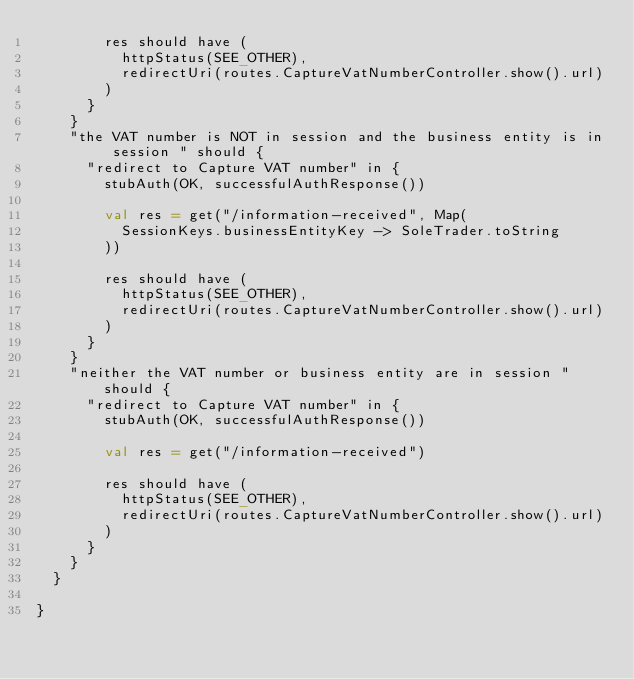<code> <loc_0><loc_0><loc_500><loc_500><_Scala_>        res should have (
          httpStatus(SEE_OTHER),
          redirectUri(routes.CaptureVatNumberController.show().url)
        )
      }
    }
    "the VAT number is NOT in session and the business entity is in session " should {
      "redirect to Capture VAT number" in {
        stubAuth(OK, successfulAuthResponse())

        val res = get("/information-received", Map(
          SessionKeys.businessEntityKey -> SoleTrader.toString
        ))

        res should have (
          httpStatus(SEE_OTHER),
          redirectUri(routes.CaptureVatNumberController.show().url)
        )
      }
    }
    "neither the VAT number or business entity are in session " should {
      "redirect to Capture VAT number" in {
        stubAuth(OK, successfulAuthResponse())

        val res = get("/information-received")

        res should have (
          httpStatus(SEE_OTHER),
          redirectUri(routes.CaptureVatNumberController.show().url)
        )
      }
    }
  }

}
</code> 